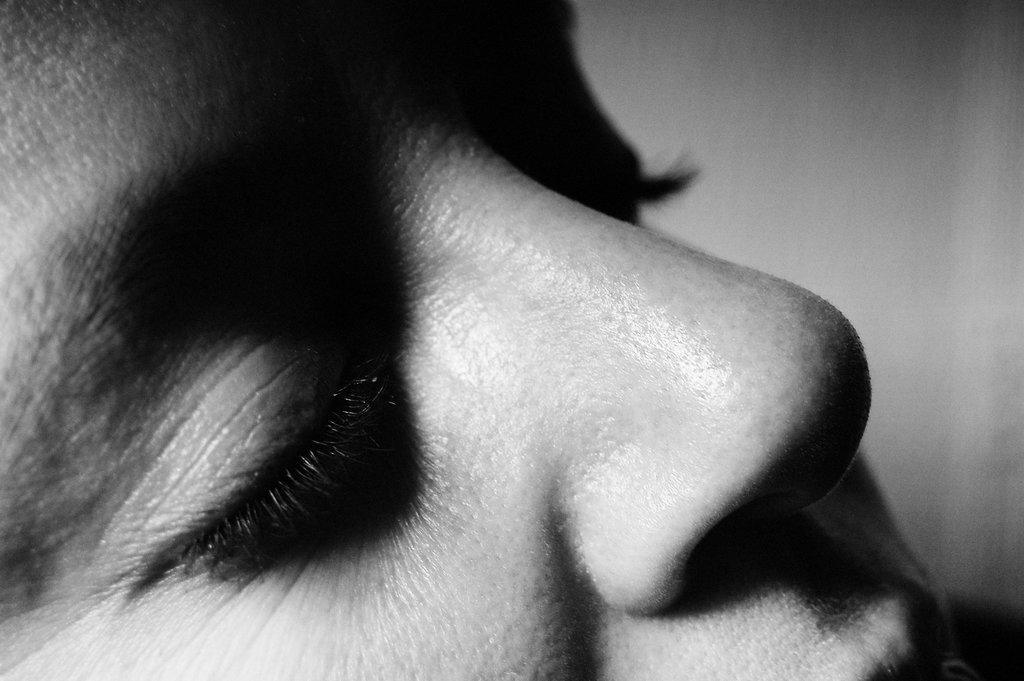What is the main subject of the image? There is a human face in the image. What facial features can be seen in the image? The image contains eyes and a nose. What is the color scheme of the image? The image is in black and white. Can you tell me how many docks are visible in the image? There are no docks present in the image; it features a human face with eyes and a nose in black and white. Is there a spy observing the scene in the image? There is no indication of a spy or any other person in the image, as it only features a human face with eyes and a nose in black and white. 